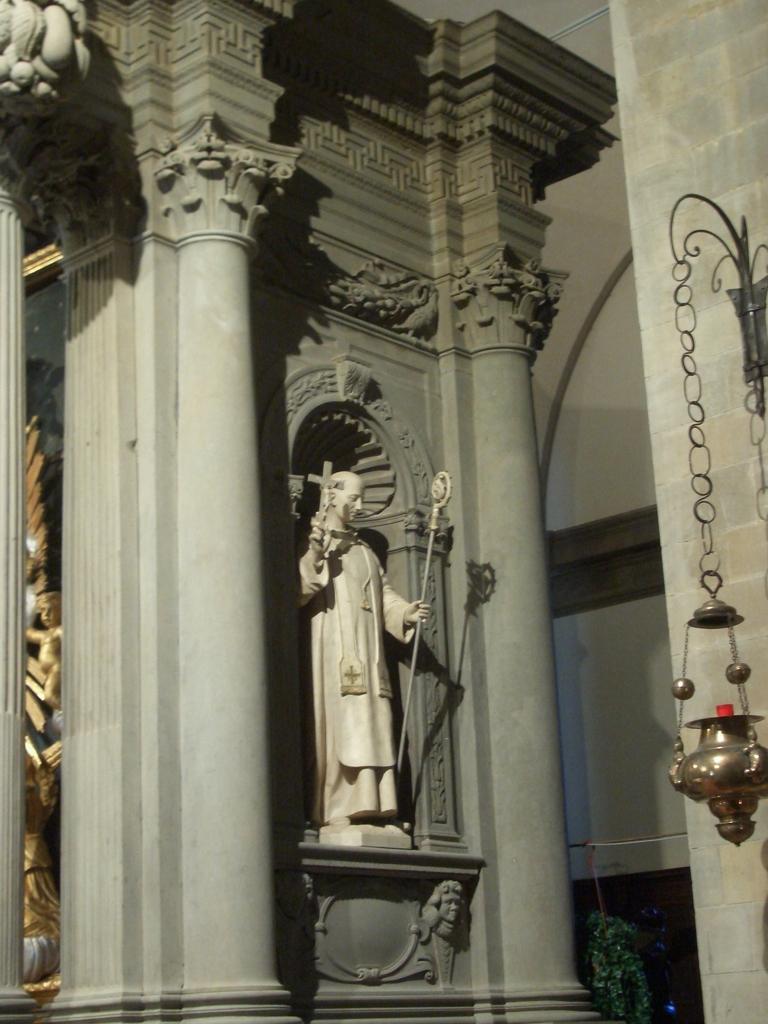Describe this image in one or two sentences. In this image we can see a statue, lamp, hooks and pillars. 